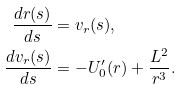<formula> <loc_0><loc_0><loc_500><loc_500>\frac { d r ( s ) } { d s } & = v _ { r } ( s ) , \\ \frac { d v _ { r } ( s ) } { d s } & = - U _ { 0 } ^ { \prime } ( r ) + \frac { L ^ { 2 } } { r ^ { 3 } } .</formula> 